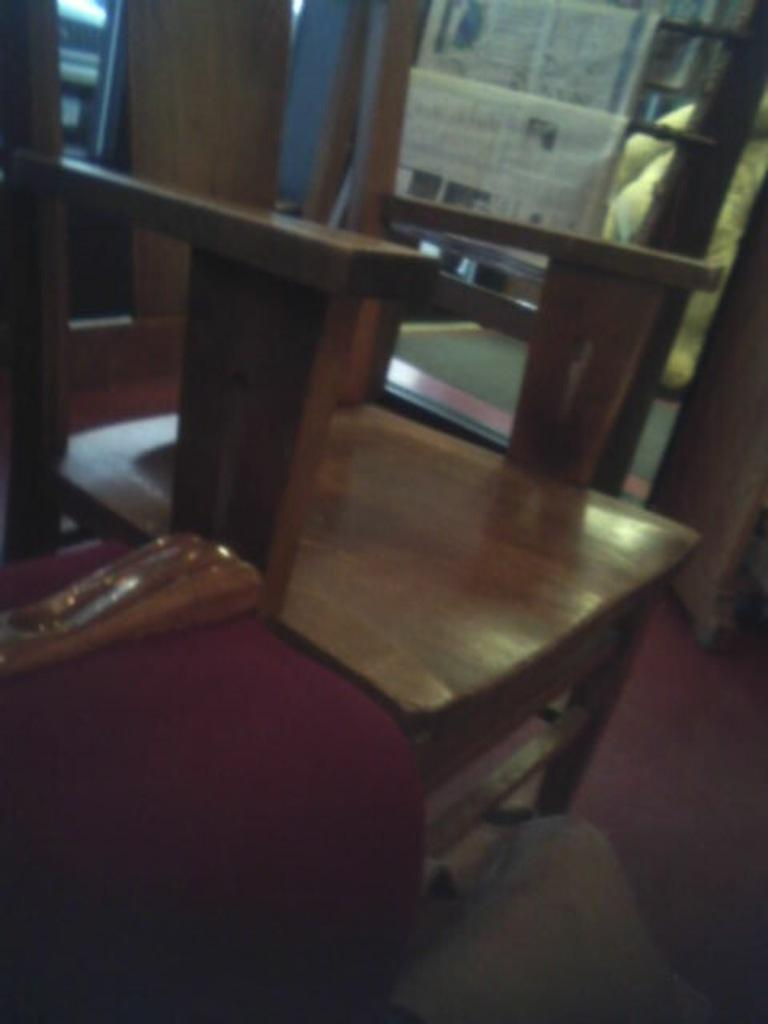What type of chair is in the image? There is a wooden chair in the image. What can be seen on the left side of the chair? There are objects on the left side of the chair. Where are the papers located in the image? The papers are on an object behind the chair. Can you tell me how many flies are sitting on the chair in the image? There are no flies present in the image. Who is the aunt mentioned in the image? There is no mention of an aunt in the image. 